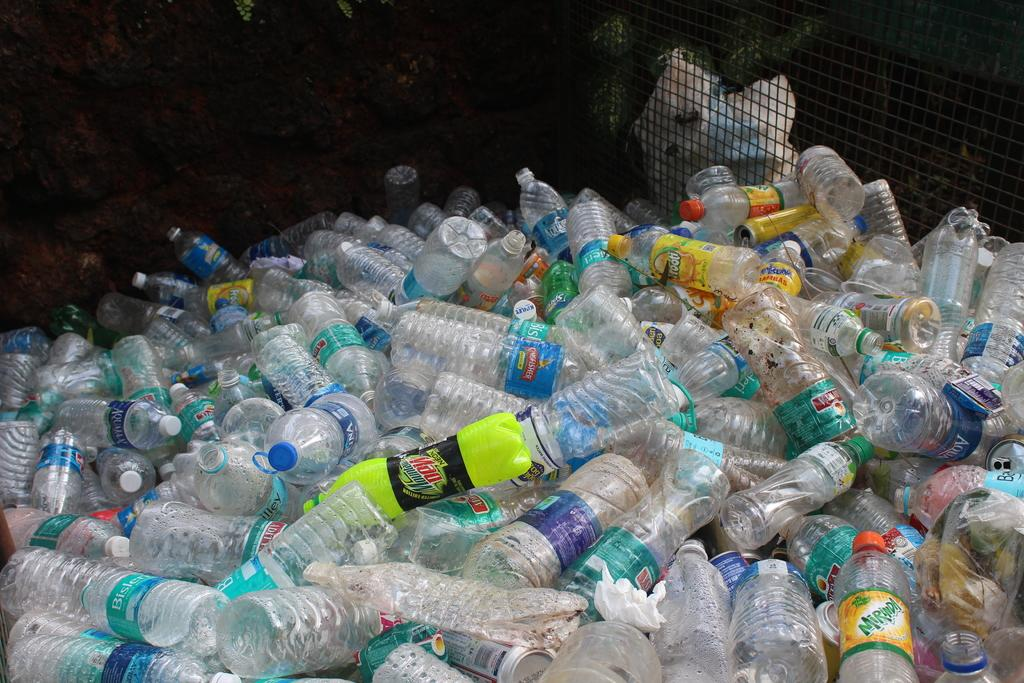<image>
Offer a succinct explanation of the picture presented. Lime green Mountain Dew bottle on top of other empty plastic bottles. 